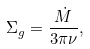<formula> <loc_0><loc_0><loc_500><loc_500>\Sigma _ { g } = \frac { \dot { M } } { 3 \pi \nu } ,</formula> 